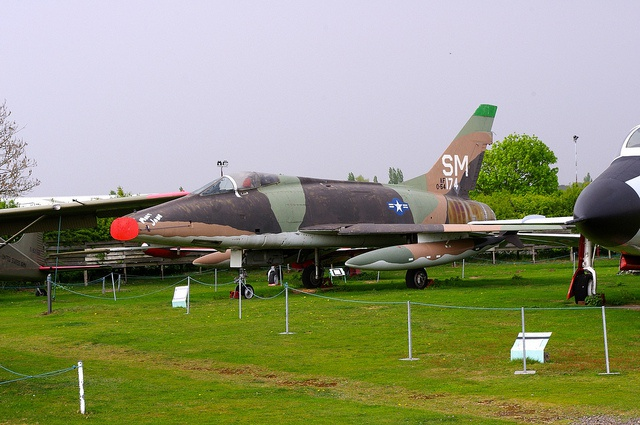Describe the objects in this image and their specific colors. I can see airplane in lavender, gray, black, and darkgray tones, airplane in lavender, black, lightgray, gray, and darkgreen tones, and airplane in lavender, black, gray, and white tones in this image. 